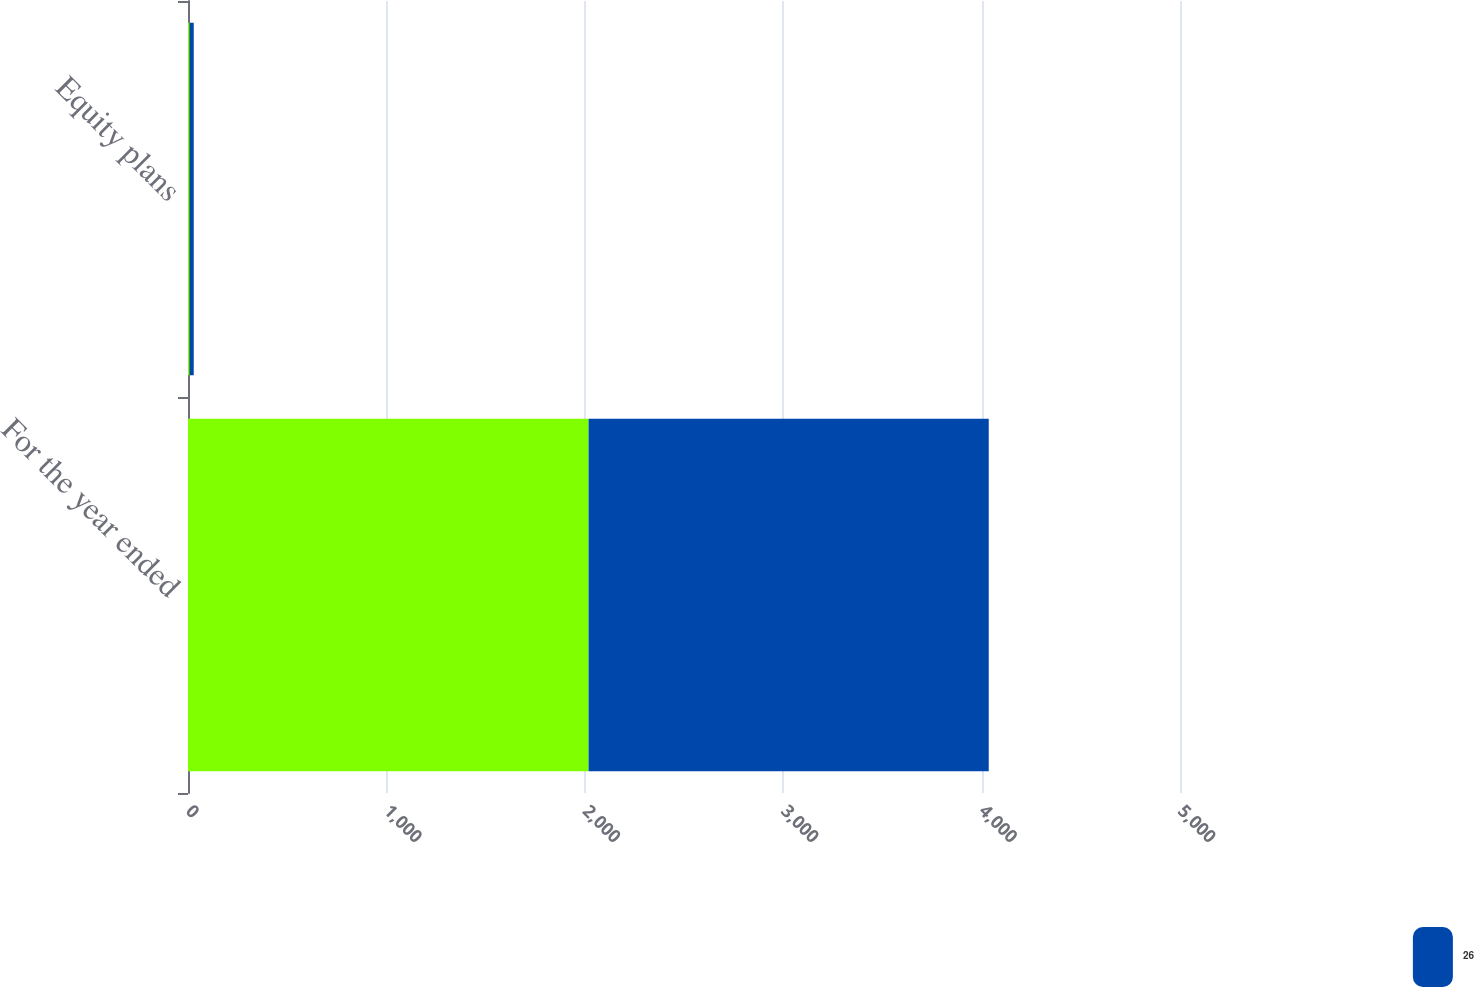Convert chart. <chart><loc_0><loc_0><loc_500><loc_500><stacked_bar_chart><ecel><fcel>For the year ended<fcel>Equity plans<nl><fcel>nan<fcel>2019<fcel>8<nl><fcel>26<fcel>2017<fcel>21<nl></chart> 